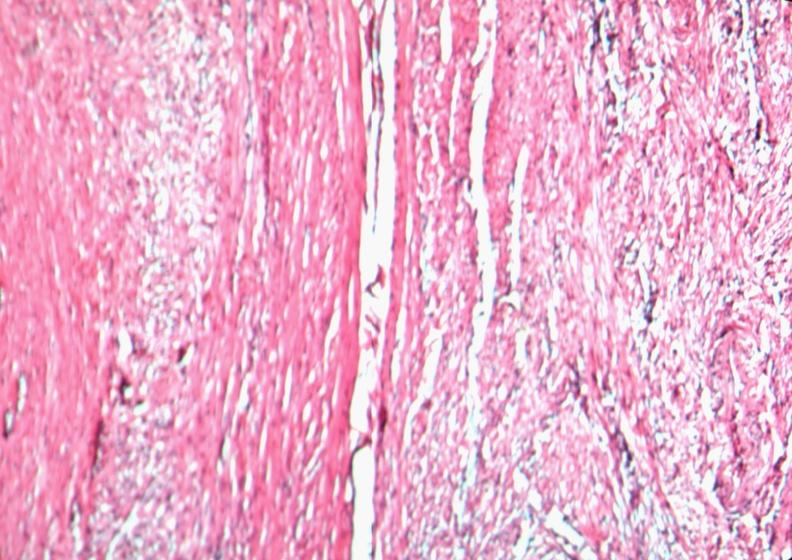does all the fat necrosis show uterus, leiomyoma?
Answer the question using a single word or phrase. No 